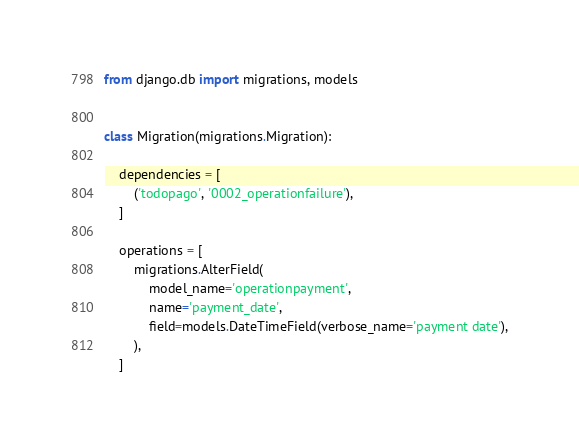<code> <loc_0><loc_0><loc_500><loc_500><_Python_>from django.db import migrations, models


class Migration(migrations.Migration):

    dependencies = [
        ('todopago', '0002_operationfailure'),
    ]

    operations = [
        migrations.AlterField(
            model_name='operationpayment',
            name='payment_date',
            field=models.DateTimeField(verbose_name='payment date'),
        ),
    ]
</code> 